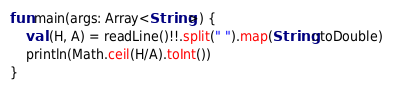<code> <loc_0><loc_0><loc_500><loc_500><_Kotlin_>fun main(args: Array<String>) {
    val (H, A) = readLine()!!.split(" ").map(String::toDouble)
    println(Math.ceil(H/A).toInt())
}</code> 